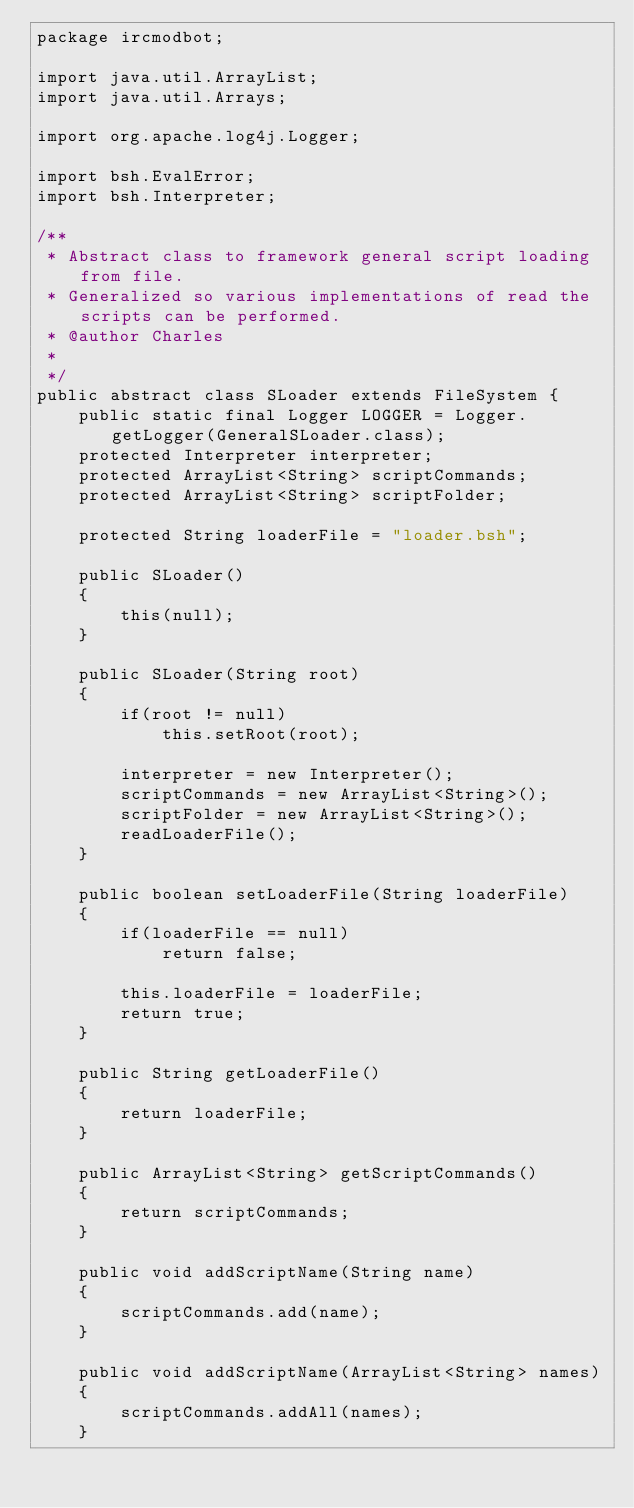Convert code to text. <code><loc_0><loc_0><loc_500><loc_500><_Java_>package ircmodbot;

import java.util.ArrayList;
import java.util.Arrays;

import org.apache.log4j.Logger;

import bsh.EvalError;
import bsh.Interpreter;

/**
 * Abstract class to framework general script loading from file.
 * Generalized so various implementations of read the scripts can be performed.
 * @author Charles
 *
 */
public abstract class SLoader extends FileSystem {
	public static final Logger LOGGER = Logger.getLogger(GeneralSLoader.class);
	protected Interpreter interpreter;
	protected ArrayList<String> scriptCommands;
	protected ArrayList<String> scriptFolder;

	protected String loaderFile = "loader.bsh";
	
	public SLoader()
	{
		this(null);
	}
	
	public SLoader(String root)
	{
		if(root != null)
			this.setRoot(root);

		interpreter = new Interpreter();
		scriptCommands = new ArrayList<String>();
		scriptFolder = new ArrayList<String>();
		readLoaderFile();
	}
	
	public boolean setLoaderFile(String loaderFile)
	{
		if(loaderFile == null)
			return false;
		
		this.loaderFile = loaderFile;
		return true;
	}

	public String getLoaderFile()
	{
		return loaderFile;
	}
	
	public ArrayList<String> getScriptCommands()
	{
		return scriptCommands;
	}
	
	public void addScriptName(String name)
	{
		scriptCommands.add(name);
	}
	
	public void addScriptName(ArrayList<String> names)
	{
		scriptCommands.addAll(names);
	}
	</code> 